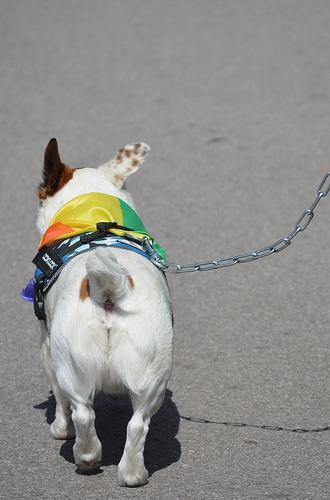How many dogs are in the photo?
Give a very brief answer. 1. 